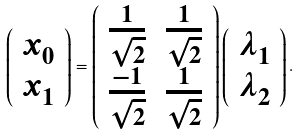<formula> <loc_0><loc_0><loc_500><loc_500>\left ( \begin{array} { c } x _ { 0 } \\ x _ { 1 } \end{array} \right ) = \left ( \begin{array} { c c } \frac { 1 } { \sqrt { 2 } } & \frac { 1 } { \sqrt { 2 } } \\ \frac { - 1 } { \sqrt { 2 } } & \frac { 1 } { \sqrt { 2 } } \end{array} \right ) \left ( \begin{array} { c } \lambda _ { 1 } \\ \lambda _ { 2 } \end{array} \right ) .</formula> 